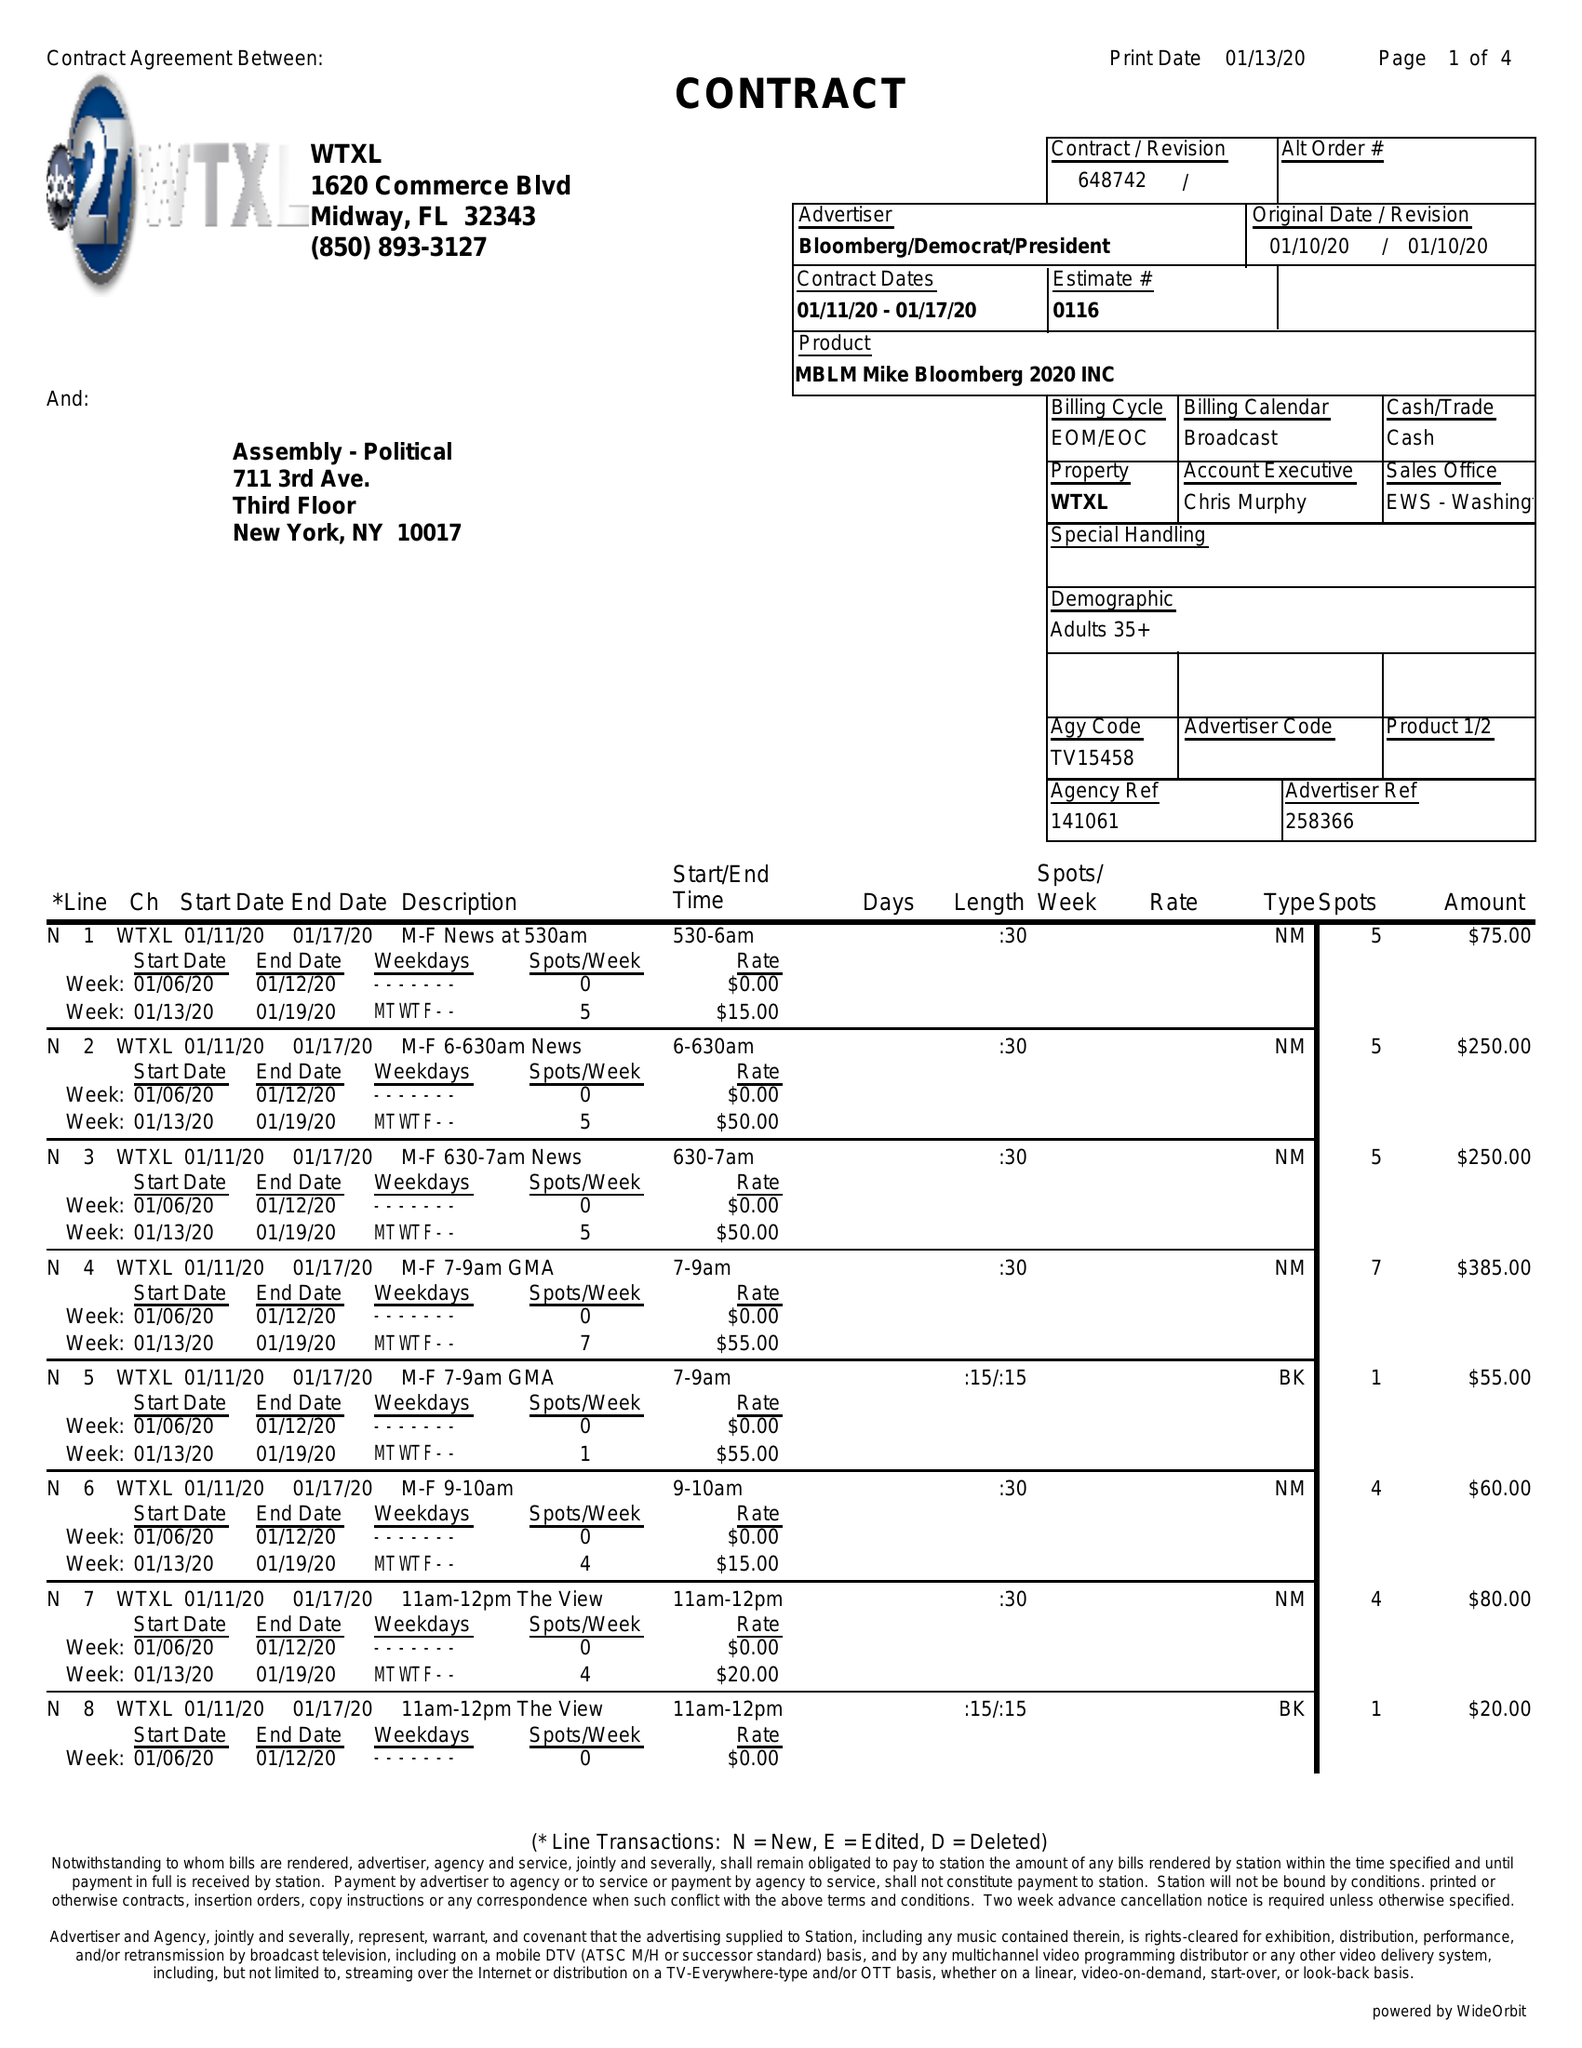What is the value for the advertiser?
Answer the question using a single word or phrase. BLOOMBERG/DEMOCRAT/PRESIDENT 